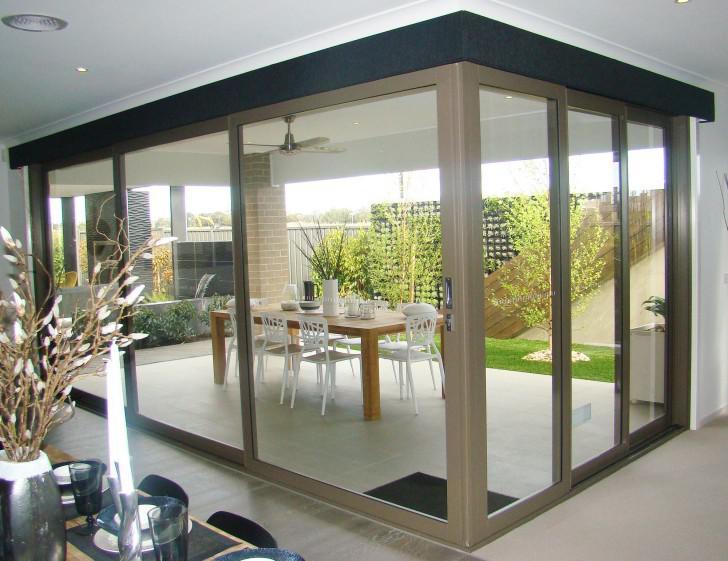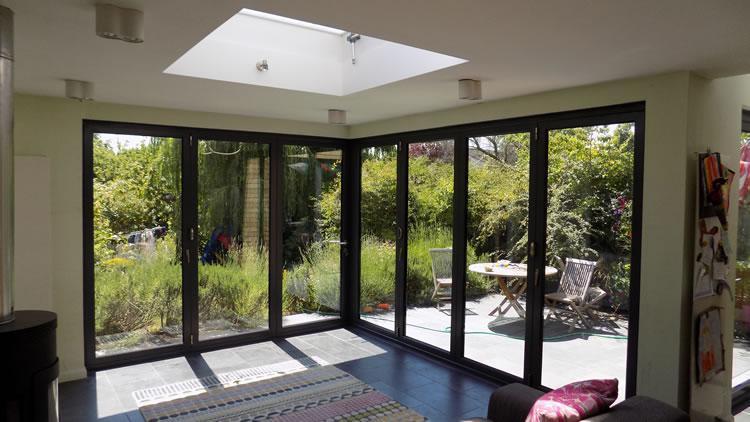The first image is the image on the left, the second image is the image on the right. Assess this claim about the two images: "The doors are open in the right image.". Correct or not? Answer yes or no. No. 